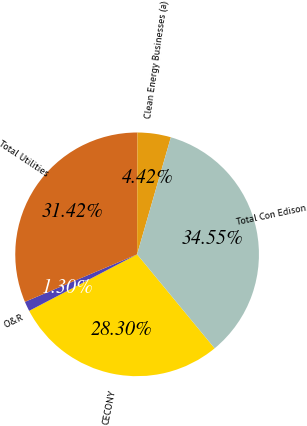<chart> <loc_0><loc_0><loc_500><loc_500><pie_chart><fcel>CECONY<fcel>O&R<fcel>Total Utilities<fcel>Clean Energy Businesses (a)<fcel>Total Con Edison<nl><fcel>28.3%<fcel>1.3%<fcel>31.42%<fcel>4.42%<fcel>34.55%<nl></chart> 